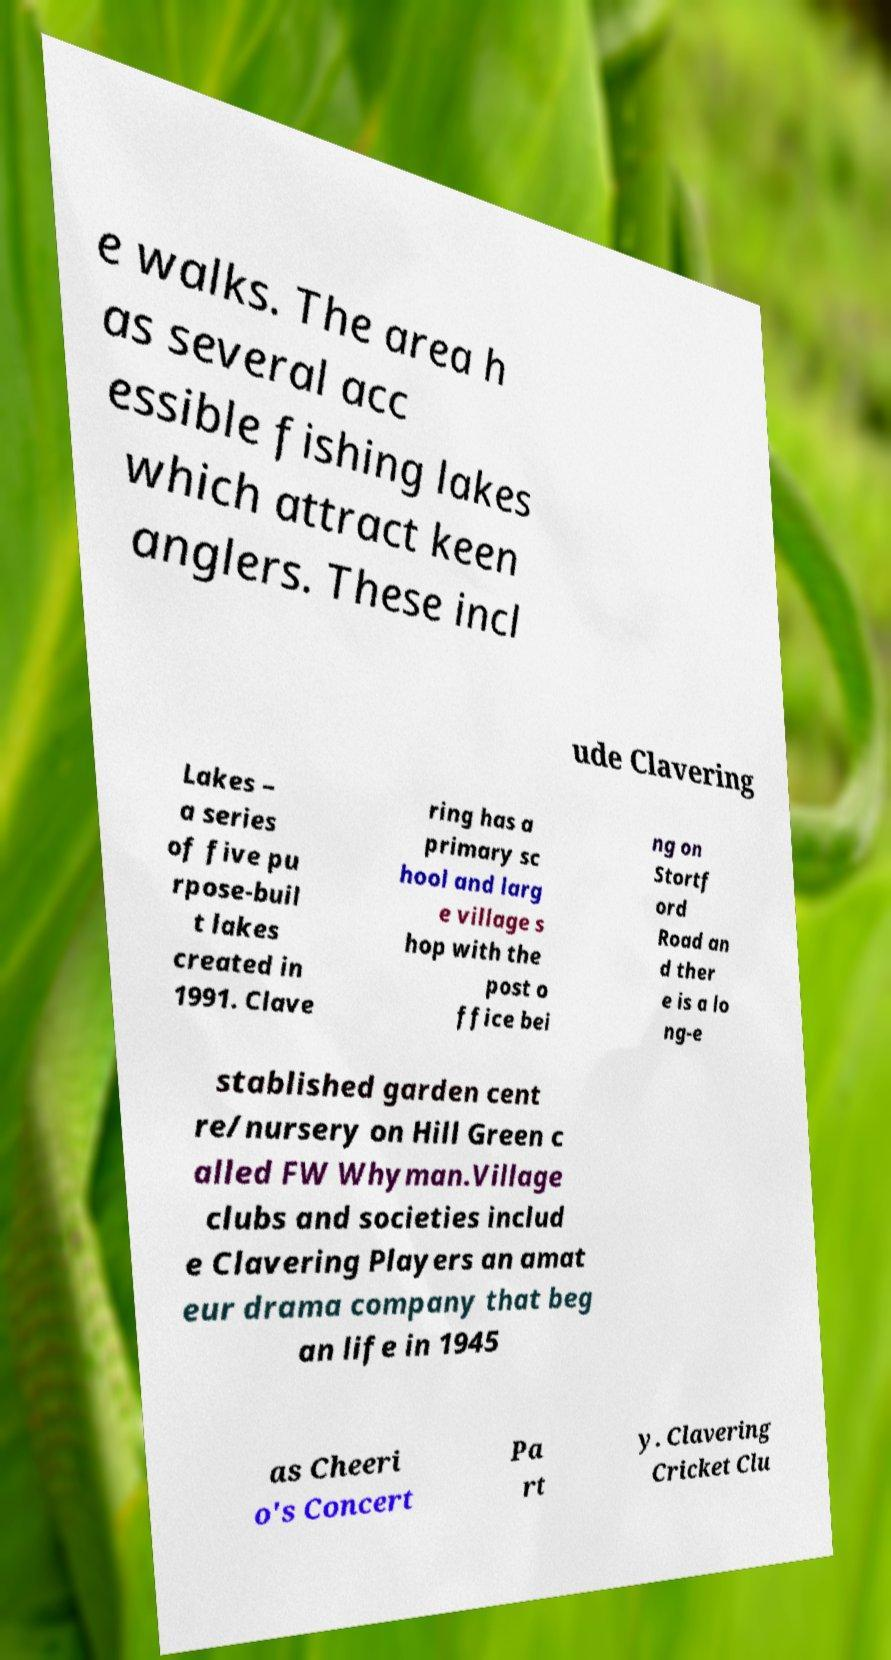For documentation purposes, I need the text within this image transcribed. Could you provide that? e walks. The area h as several acc essible fishing lakes which attract keen anglers. These incl ude Clavering Lakes – a series of five pu rpose-buil t lakes created in 1991. Clave ring has a primary sc hool and larg e village s hop with the post o ffice bei ng on Stortf ord Road an d ther e is a lo ng-e stablished garden cent re/nursery on Hill Green c alled FW Whyman.Village clubs and societies includ e Clavering Players an amat eur drama company that beg an life in 1945 as Cheeri o's Concert Pa rt y. Clavering Cricket Clu 